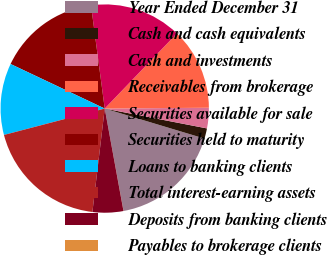<chart> <loc_0><loc_0><loc_500><loc_500><pie_chart><fcel>Year Ended December 31<fcel>Cash and cash equivalents<fcel>Cash and investments<fcel>Receivables from brokerage<fcel>Securities available for sale<fcel>Securities held to maturity<fcel>Loans to banking clients<fcel>Total interest-earning assets<fcel>Deposits from banking clients<fcel>Payables to brokerage clients<nl><fcel>17.45%<fcel>1.6%<fcel>3.18%<fcel>12.69%<fcel>14.28%<fcel>15.86%<fcel>11.11%<fcel>19.03%<fcel>4.77%<fcel>0.01%<nl></chart> 